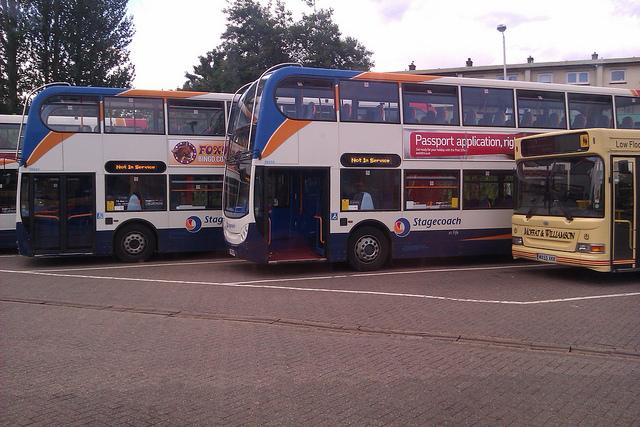How many colors on the bus?
Be succinct. 4. Are all of the buses in this photo the same kind?
Quick response, please. No. Are all the buses double Decker buses?
Short answer required. No. How many buses are parked?
Be succinct. 4. 